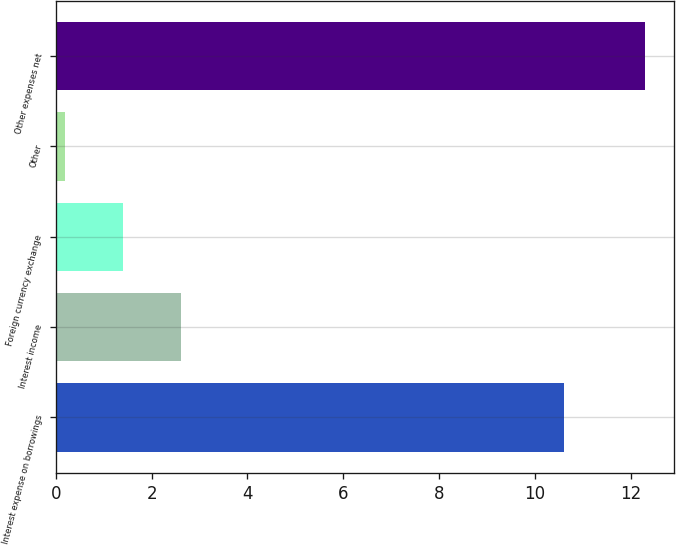Convert chart. <chart><loc_0><loc_0><loc_500><loc_500><bar_chart><fcel>Interest expense on borrowings<fcel>Interest income<fcel>Foreign currency exchange<fcel>Other<fcel>Other expenses net<nl><fcel>10.6<fcel>2.62<fcel>1.41<fcel>0.2<fcel>12.3<nl></chart> 